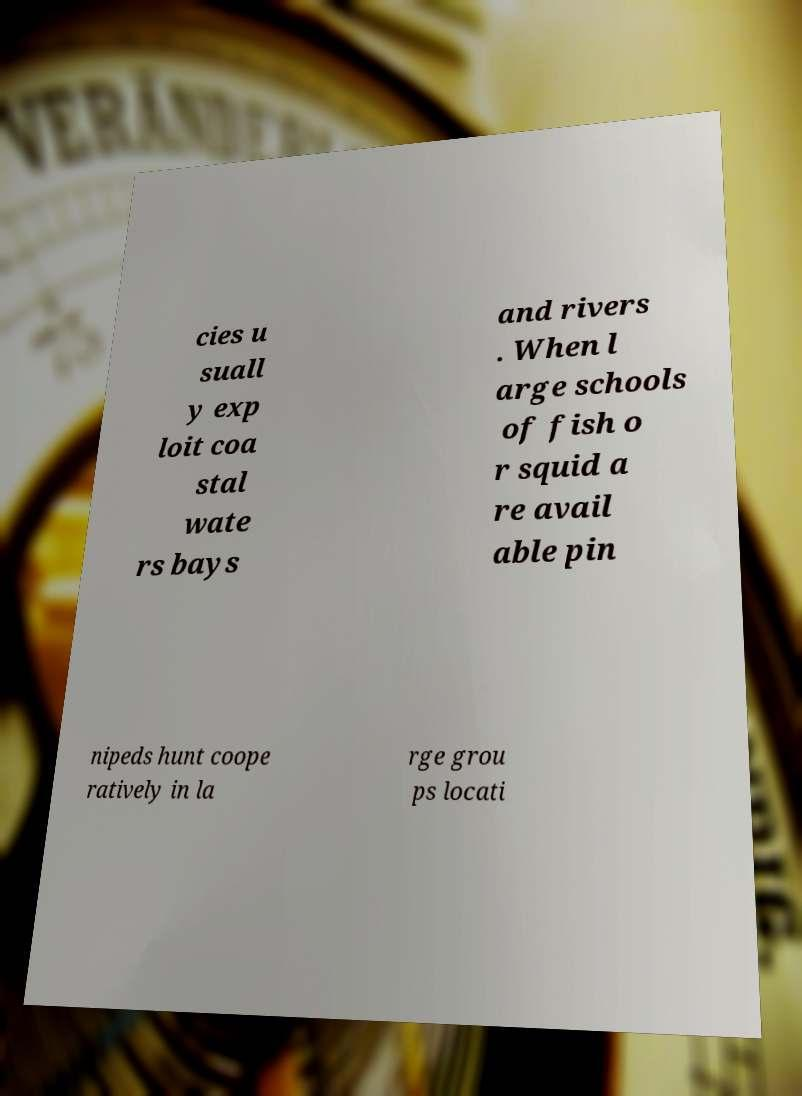Could you extract and type out the text from this image? cies u suall y exp loit coa stal wate rs bays and rivers . When l arge schools of fish o r squid a re avail able pin nipeds hunt coope ratively in la rge grou ps locati 